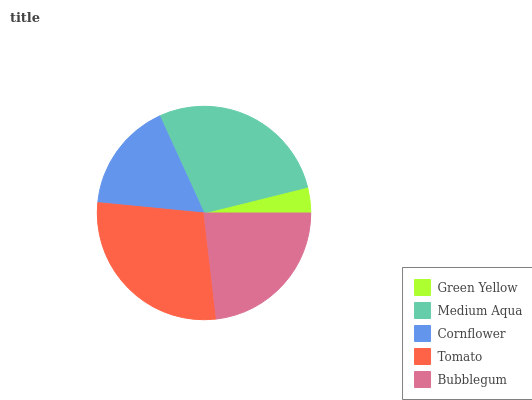Is Green Yellow the minimum?
Answer yes or no. Yes. Is Tomato the maximum?
Answer yes or no. Yes. Is Medium Aqua the minimum?
Answer yes or no. No. Is Medium Aqua the maximum?
Answer yes or no. No. Is Medium Aqua greater than Green Yellow?
Answer yes or no. Yes. Is Green Yellow less than Medium Aqua?
Answer yes or no. Yes. Is Green Yellow greater than Medium Aqua?
Answer yes or no. No. Is Medium Aqua less than Green Yellow?
Answer yes or no. No. Is Bubblegum the high median?
Answer yes or no. Yes. Is Bubblegum the low median?
Answer yes or no. Yes. Is Medium Aqua the high median?
Answer yes or no. No. Is Green Yellow the low median?
Answer yes or no. No. 